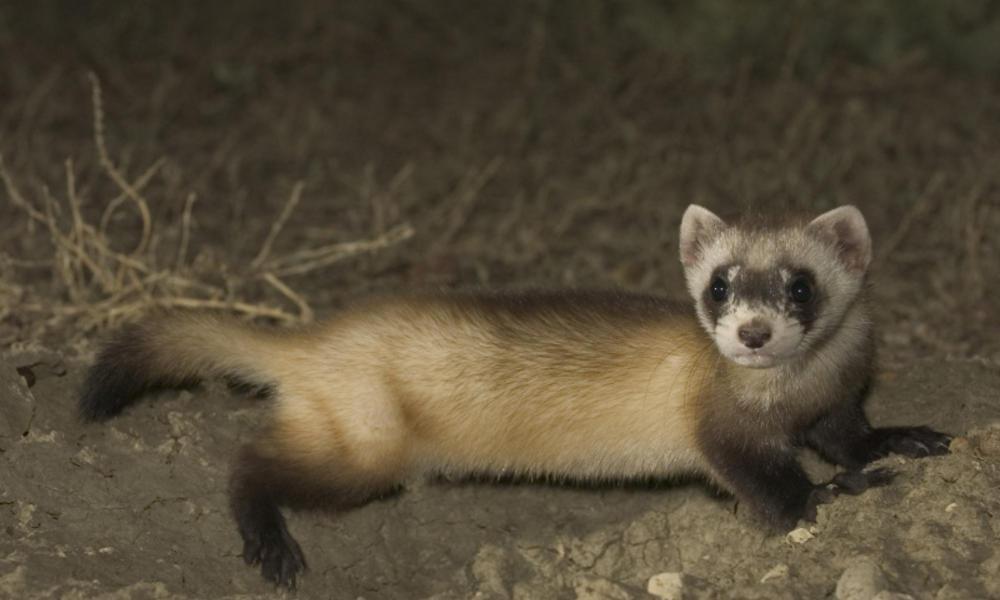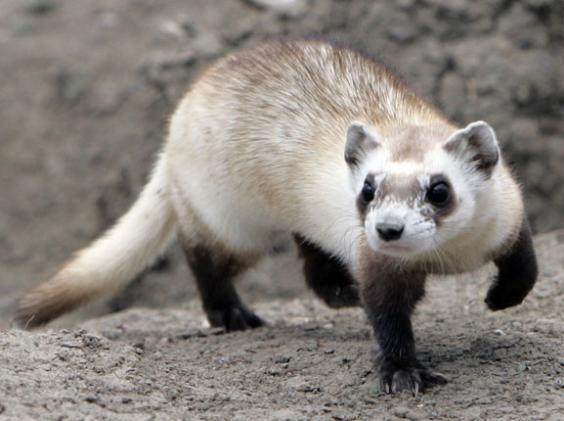The first image is the image on the left, the second image is the image on the right. For the images displayed, is the sentence "Each image contains one ferret, and no ferrets are emerging from a hole in the ground." factually correct? Answer yes or no. Yes. The first image is the image on the left, the second image is the image on the right. For the images shown, is this caption "An image contains a prairie dog coming out of a hole." true? Answer yes or no. No. 